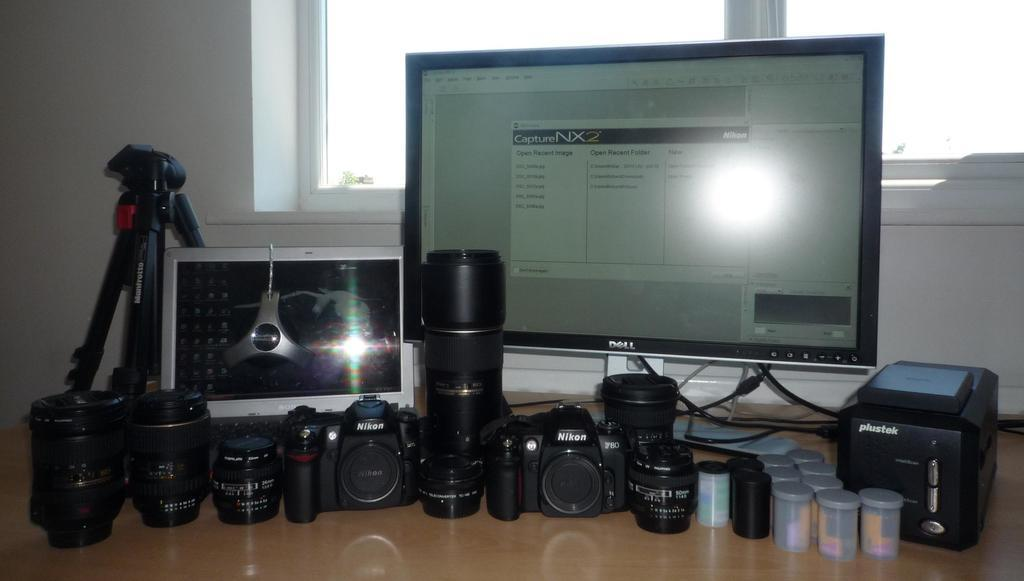What type of electronic devices can be seen in the image? There are cameras, a laptop, and a monitor in the image. What objects are used for capturing or displaying visual content? The cameras and monitor are used for capturing or displaying visual content. What is the purpose of the tripod stand in the image? The tripod stand is likely used to support and stabilize the cameras. What type of containers are present in the image? There are jars in the image. Where are all these objects placed? All these objects are placed on a table. What can be seen in the background of the image? There is a window visible in the background of the image. What type of basin is used for washing hands in the image? There is no basin present in the image for washing hands. How does the laptop show care for the environment in the image? The image does not provide information about the laptop's impact on the environment or any actions related to care for the environment. 